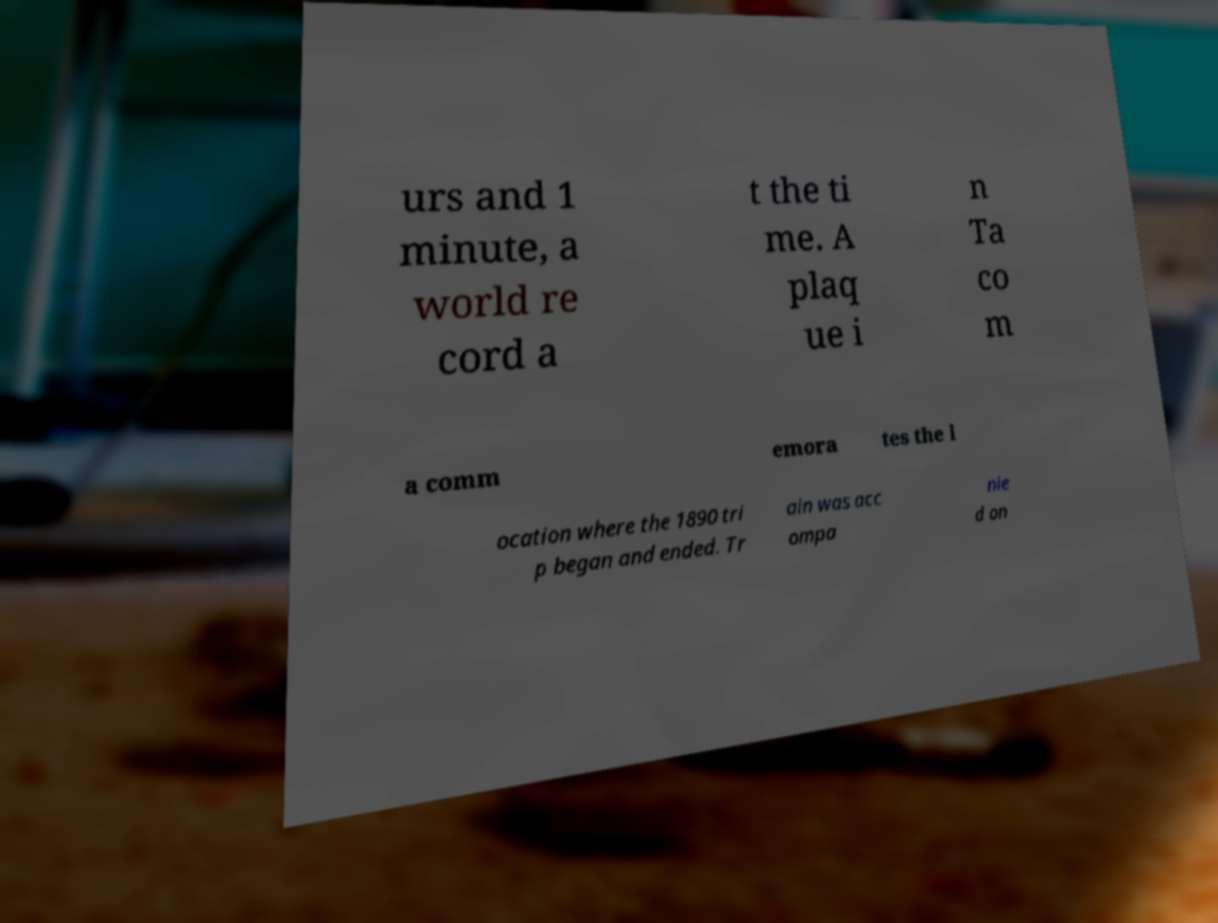Can you read and provide the text displayed in the image?This photo seems to have some interesting text. Can you extract and type it out for me? urs and 1 minute, a world re cord a t the ti me. A plaq ue i n Ta co m a comm emora tes the l ocation where the 1890 tri p began and ended. Tr ain was acc ompa nie d on 